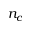Convert formula to latex. <formula><loc_0><loc_0><loc_500><loc_500>n _ { c }</formula> 